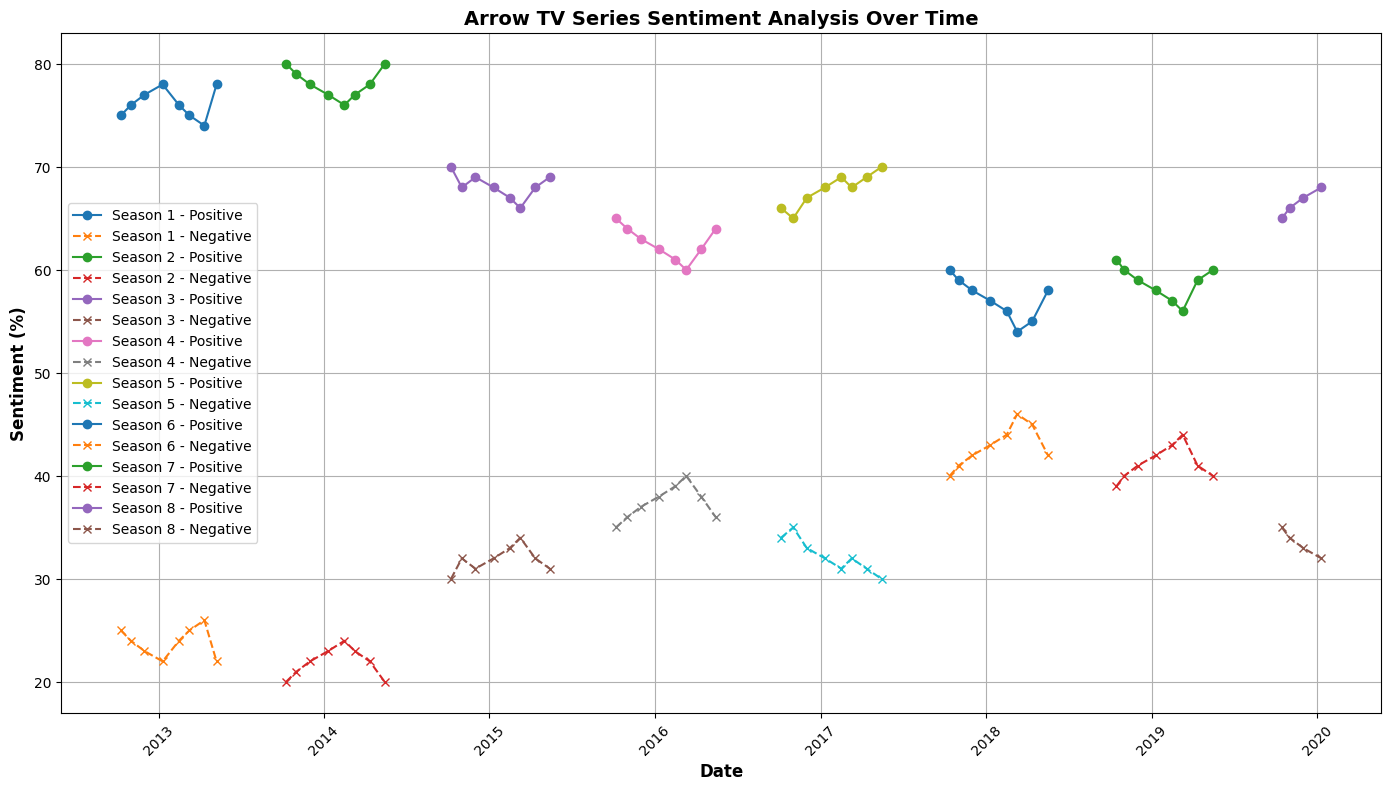What's the trend of Positive Sentiment for Season 3? Looking at the line representing Positive Sentiment for Season 3, it starts at 70% in October 2014 and generally declines, reaching a low of 66% by May 2015, with minor fluctuations in between.
Answer: Declining How does the Negative Sentiment for Season 4 compare to Season 5 in January? In January, Negative Sentiment in Season 4 is 38%, while in Season 5 it decreases to 32%. This shows an improvement in Negative Sentiment between these two seasons.
Answer: Improved Which season has the highest peak in Positive Sentiment and what is the value? The highest peak in Positive Sentiment is in Season 2, reaching 80% in October 2013 and May 2014.
Answer: Season 2, 80% What is the average Positive Sentiment for Season 1? Sum the Positive Sentiment percentages from Season 1: 75 + 76 + 77 + 78 + 76 + 75 + 74 + 78 = 609. There are 8 data points, hence the average is 609/8.
Answer: 76.125 In which season and month does Negative Sentiment reach its peak? Negative Sentiment peaks at 46% in March 2018, during Season 6.
Answer: Season 6, March 2018 Compare the overall trend of Positive Sentiment between Season 1 and Season 4. In Season 1, Positive Sentiment fluctuates but generally remains high, starting at 75% and ending at 78%. In Season 4, it starts at 65% and steadily declines each month, bottoming out at 60%. This indicates a more positive reception in Season 1 compared to Season 4.
Answer: Season 1 higher How do Positive and Negative Sentiments change over each season's timeline? Positive Sentiment typically starts high and may fluctuate or decline over time, while Negative Sentiment displays the opposite pattern. Positive markers ('o') and Negative markers ('x') help visualize these patterns for each season.
Answer: Varies per season Which season shows the most variation in Positive Sentiment values? Season 3 shows the most variation, ranging from a high of 70% to a low of 66%. This fluctuation is more pronounced compared to other seasons.
Answer: Season 3 What visual attributes are used to differentiate Positive and Negative Sentiments on the plot? Positive Sentiments are represented by solid lines and circles, and Negative Sentiments by dashed lines and crosses. Each season has a different color for both Positive and Negative Sentiments.
Answer: Lines and markers 